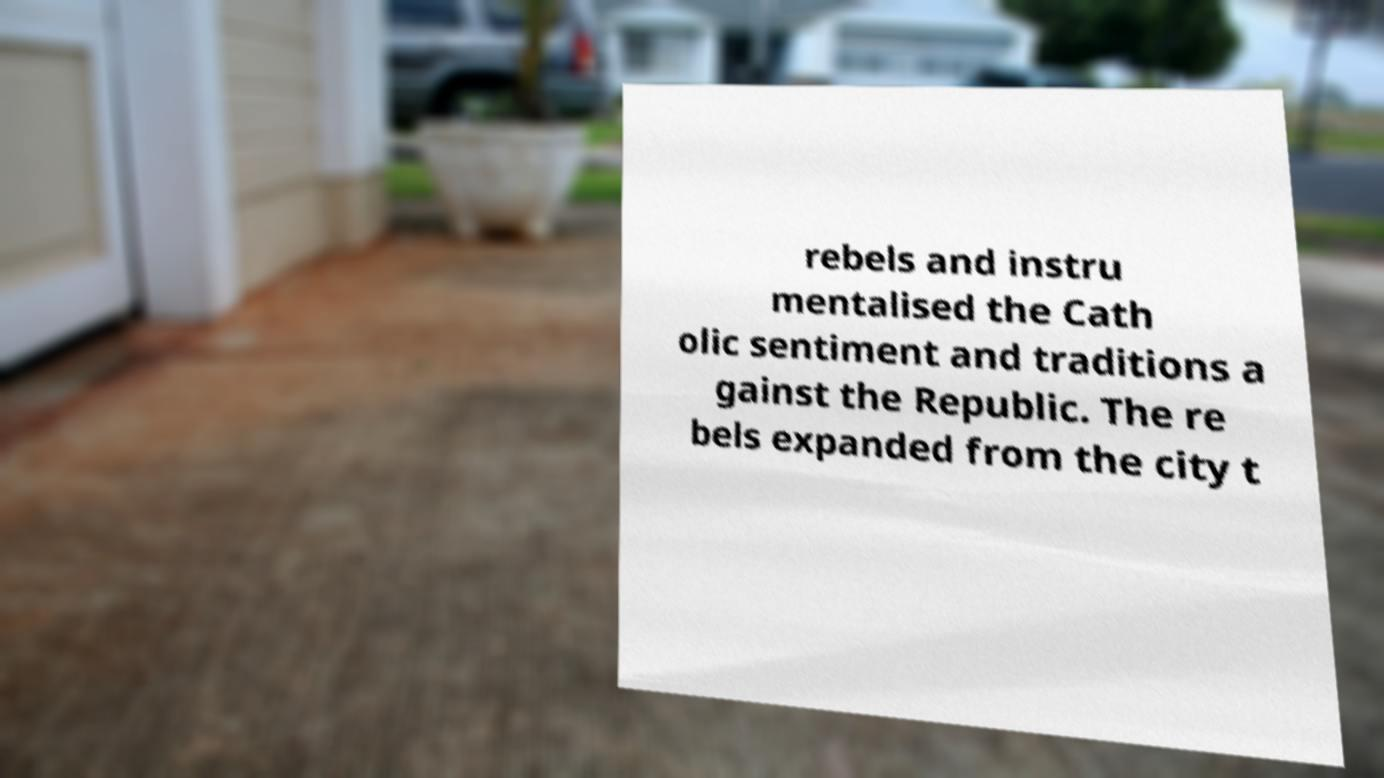I need the written content from this picture converted into text. Can you do that? rebels and instru mentalised the Cath olic sentiment and traditions a gainst the Republic. The re bels expanded from the city t 